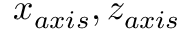Convert formula to latex. <formula><loc_0><loc_0><loc_500><loc_500>x _ { a x i s } , z _ { a x i s }</formula> 